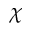<formula> <loc_0><loc_0><loc_500><loc_500>\chi</formula> 